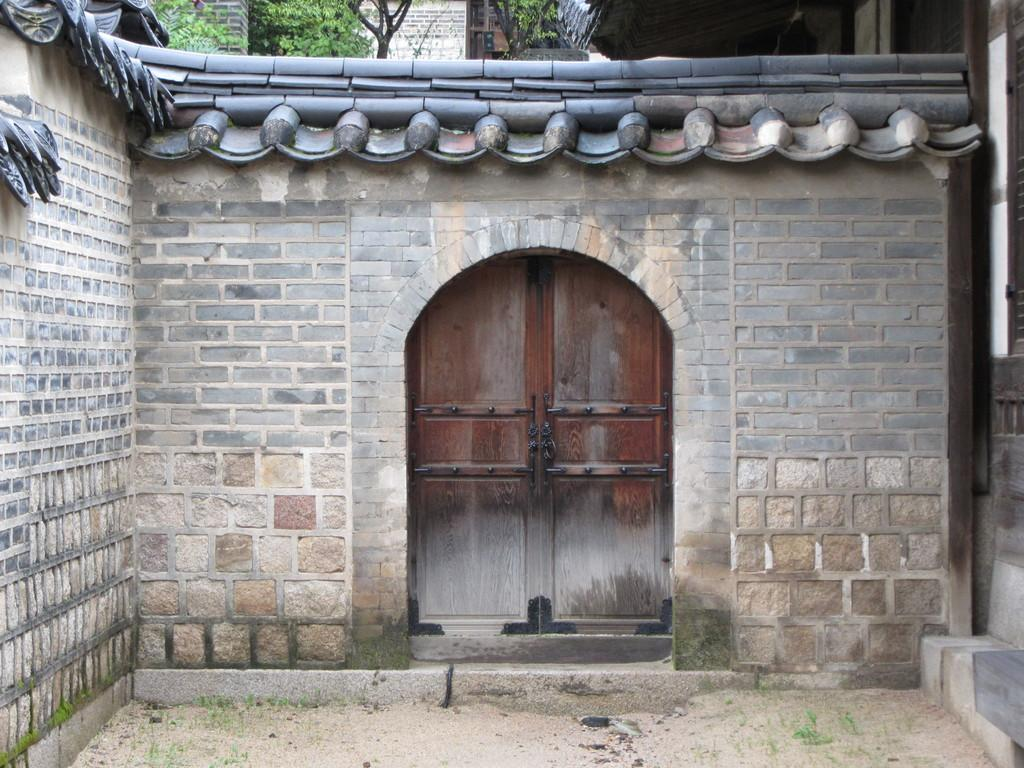What type of structure is shown in the image? The image depicts a house. How many laborers are working on the house in the image? There is no information about laborers or any work being done on the house in the image. What type of squirrel can be seen climbing on the roof of the house in the image? There is no squirrel present in the image; it only depicts a house. 